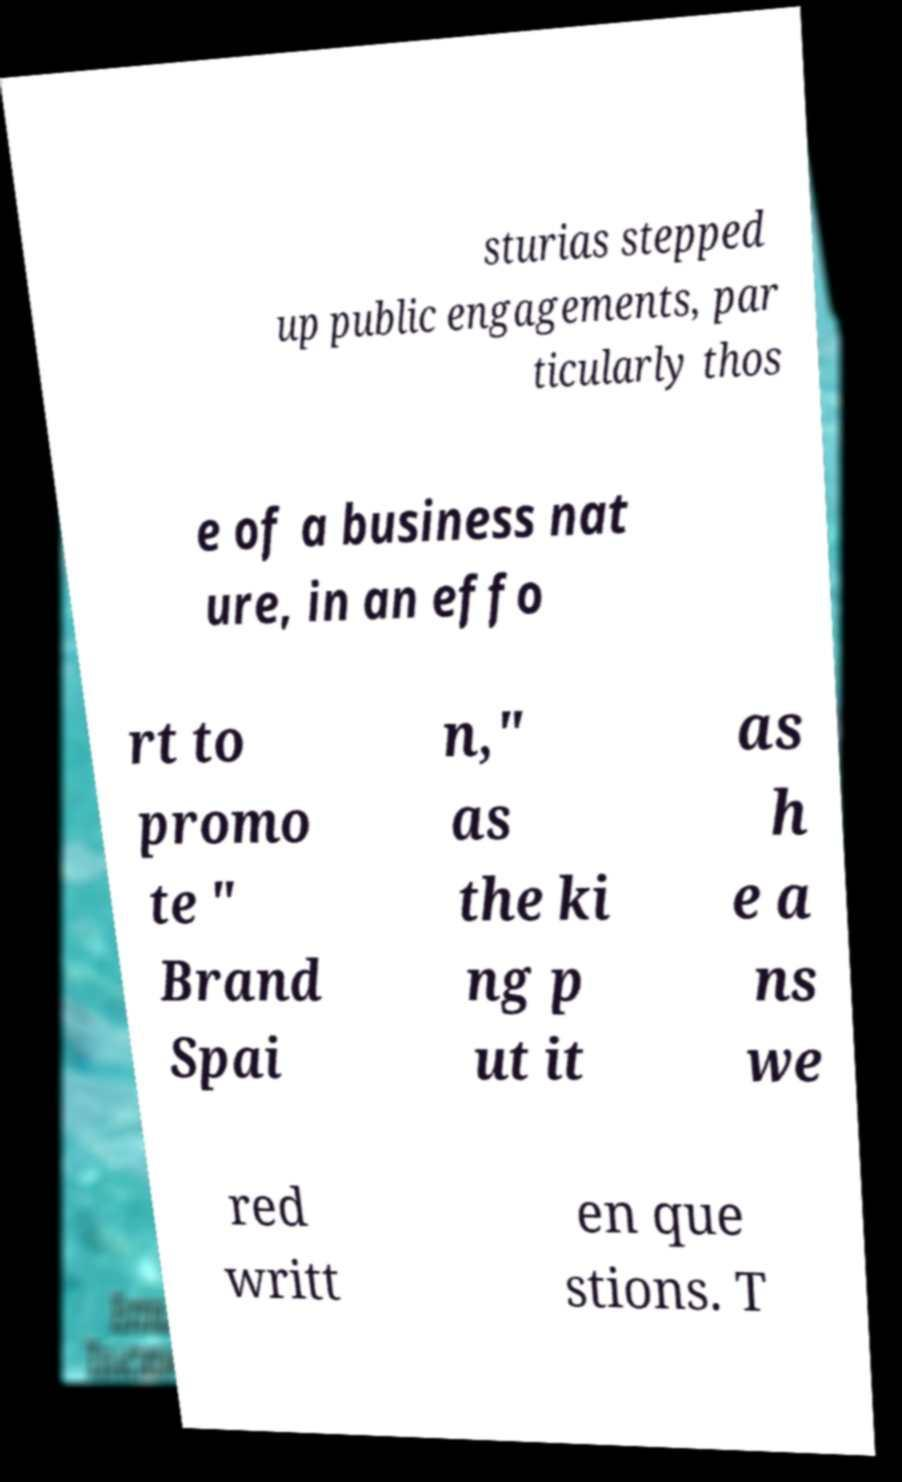Can you read and provide the text displayed in the image?This photo seems to have some interesting text. Can you extract and type it out for me? sturias stepped up public engagements, par ticularly thos e of a business nat ure, in an effo rt to promo te " Brand Spai n," as the ki ng p ut it as h e a ns we red writt en que stions. T 